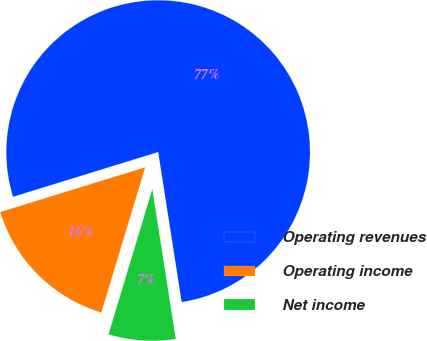<chart> <loc_0><loc_0><loc_500><loc_500><pie_chart><fcel>Operating revenues<fcel>Operating income<fcel>Net income<nl><fcel>77.29%<fcel>15.57%<fcel>7.14%<nl></chart> 